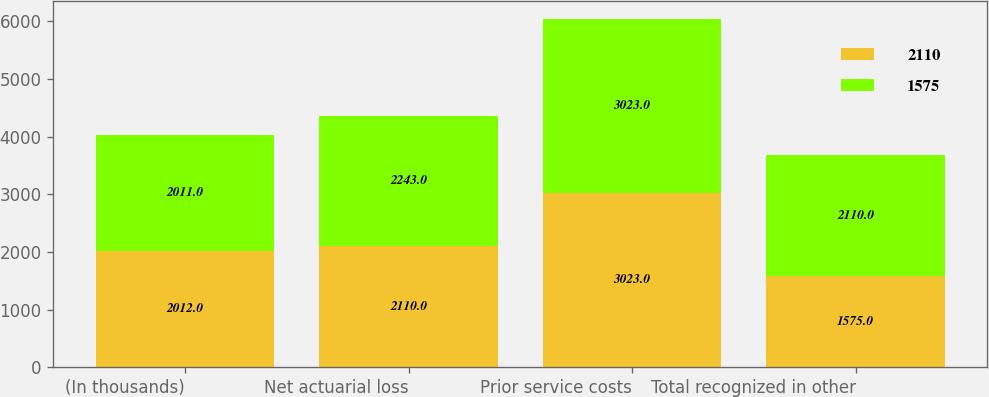Convert chart to OTSL. <chart><loc_0><loc_0><loc_500><loc_500><stacked_bar_chart><ecel><fcel>(In thousands)<fcel>Net actuarial loss<fcel>Prior service costs<fcel>Total recognized in other<nl><fcel>2110<fcel>2012<fcel>2110<fcel>3023<fcel>1575<nl><fcel>1575<fcel>2011<fcel>2243<fcel>3023<fcel>2110<nl></chart> 